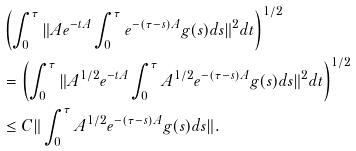Convert formula to latex. <formula><loc_0><loc_0><loc_500><loc_500>& \left ( \int _ { 0 } ^ { \tau } \| A e ^ { - t A } \int _ { 0 } ^ { \tau } e ^ { - ( \tau - s ) A } g ( s ) d s \| ^ { 2 } d t \right ) ^ { 1 / 2 } \\ & = \left ( \int _ { 0 } ^ { \tau } \| A ^ { 1 / 2 } e ^ { - t A } \int _ { 0 } ^ { \tau } A ^ { 1 / 2 } e ^ { - ( \tau - s ) A } g ( s ) d s \| ^ { 2 } d t \right ) ^ { 1 / 2 } \\ & \leq C \| \int _ { 0 } ^ { \tau } A ^ { 1 / 2 } e ^ { - ( \tau - s ) A } g ( s ) d s \| .</formula> 